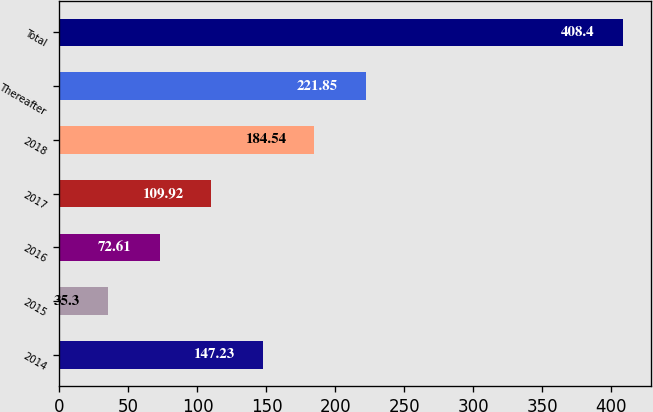<chart> <loc_0><loc_0><loc_500><loc_500><bar_chart><fcel>2014<fcel>2015<fcel>2016<fcel>2017<fcel>2018<fcel>Thereafter<fcel>Total<nl><fcel>147.23<fcel>35.3<fcel>72.61<fcel>109.92<fcel>184.54<fcel>221.85<fcel>408.4<nl></chart> 